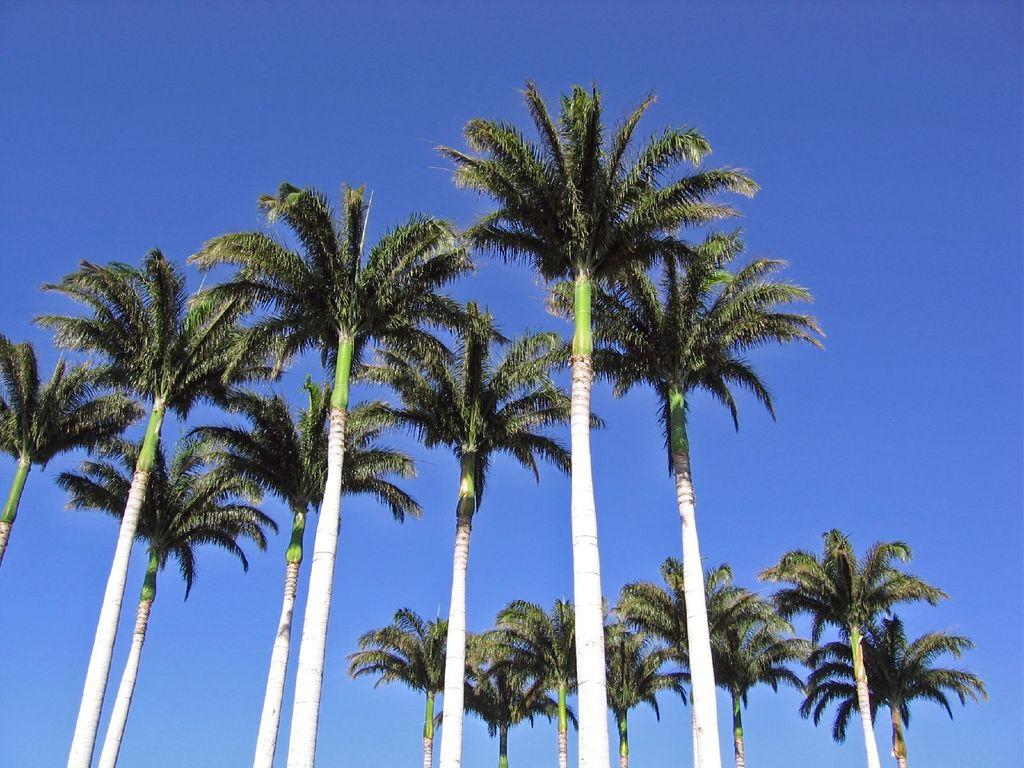What type of trees can be seen in the image? There are coconut trees in the image. What is visible at the top of the image? The sky is visible at the top of the image. Can you see a robin sitting on one of the coconut trees in the image? There is no robin present in the image; it only features coconut trees and the sky. 